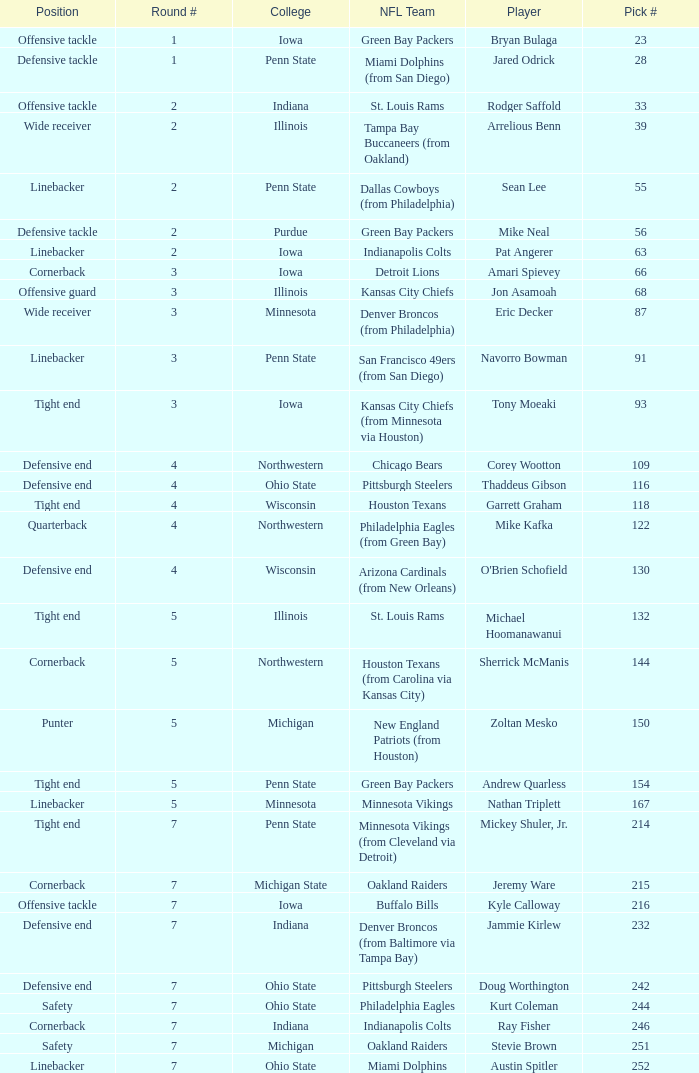What NFL team was the player with pick number 28 drafted to? Miami Dolphins (from San Diego). 